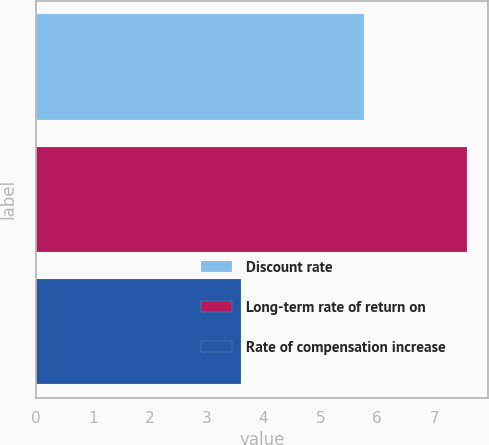Convert chart to OTSL. <chart><loc_0><loc_0><loc_500><loc_500><bar_chart><fcel>Discount rate<fcel>Long-term rate of return on<fcel>Rate of compensation increase<nl><fcel>5.77<fcel>7.57<fcel>3.6<nl></chart> 